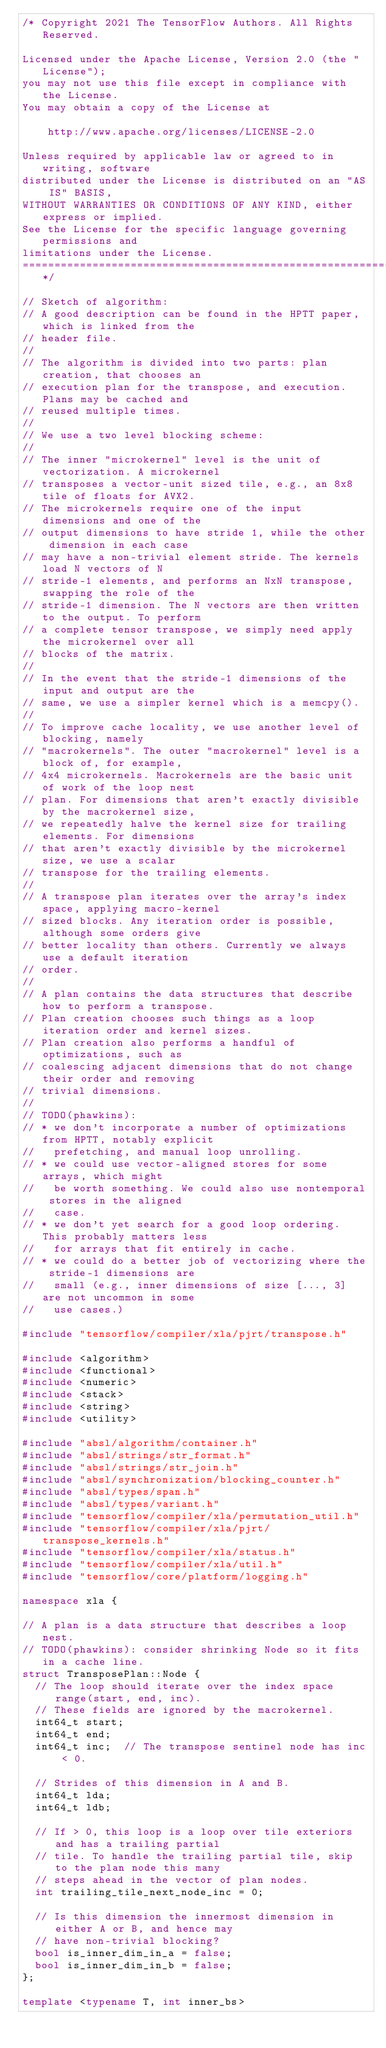<code> <loc_0><loc_0><loc_500><loc_500><_C++_>/* Copyright 2021 The TensorFlow Authors. All Rights Reserved.

Licensed under the Apache License, Version 2.0 (the "License");
you may not use this file except in compliance with the License.
You may obtain a copy of the License at

    http://www.apache.org/licenses/LICENSE-2.0

Unless required by applicable law or agreed to in writing, software
distributed under the License is distributed on an "AS IS" BASIS,
WITHOUT WARRANTIES OR CONDITIONS OF ANY KIND, either express or implied.
See the License for the specific language governing permissions and
limitations under the License.
==============================================================================*/

// Sketch of algorithm:
// A good description can be found in the HPTT paper, which is linked from the
// header file.
//
// The algorithm is divided into two parts: plan creation, that chooses an
// execution plan for the transpose, and execution. Plans may be cached and
// reused multiple times.
//
// We use a two level blocking scheme:
//
// The inner "microkernel" level is the unit of vectorization. A microkernel
// transposes a vector-unit sized tile, e.g., an 8x8 tile of floats for AVX2.
// The microkernels require one of the input dimensions and one of the
// output dimensions to have stride 1, while the other dimension in each case
// may have a non-trivial element stride. The kernels load N vectors of N
// stride-1 elements, and performs an NxN transpose, swapping the role of the
// stride-1 dimension. The N vectors are then written to the output. To perform
// a complete tensor transpose, we simply need apply the microkernel over all
// blocks of the matrix.
//
// In the event that the stride-1 dimensions of the input and output are the
// same, we use a simpler kernel which is a memcpy().
//
// To improve cache locality, we use another level of blocking, namely
// "macrokernels". The outer "macrokernel" level is a block of, for example,
// 4x4 microkernels. Macrokernels are the basic unit of work of the loop nest
// plan. For dimensions that aren't exactly divisible by the macrokernel size,
// we repeatedly halve the kernel size for trailing elements. For dimensions
// that aren't exactly divisible by the microkernel size, we use a scalar
// transpose for the trailing elements.
//
// A transpose plan iterates over the array's index space, applying macro-kernel
// sized blocks. Any iteration order is possible, although some orders give
// better locality than others. Currently we always use a default iteration
// order.
//
// A plan contains the data structures that describe how to perform a transpose.
// Plan creation chooses such things as a loop iteration order and kernel sizes.
// Plan creation also performs a handful of optimizations, such as
// coalescing adjacent dimensions that do not change their order and removing
// trivial dimensions.
//
// TODO(phawkins):
// * we don't incorporate a number of optimizations from HPTT, notably explicit
//   prefetching, and manual loop unrolling.
// * we could use vector-aligned stores for some arrays, which might
//   be worth something. We could also use nontemporal stores in the aligned
//   case.
// * we don't yet search for a good loop ordering. This probably matters less
//   for arrays that fit entirely in cache.
// * we could do a better job of vectorizing where the stride-1 dimensions are
//   small (e.g., inner dimensions of size [..., 3] are not uncommon in some
//   use cases.)

#include "tensorflow/compiler/xla/pjrt/transpose.h"

#include <algorithm>
#include <functional>
#include <numeric>
#include <stack>
#include <string>
#include <utility>

#include "absl/algorithm/container.h"
#include "absl/strings/str_format.h"
#include "absl/strings/str_join.h"
#include "absl/synchronization/blocking_counter.h"
#include "absl/types/span.h"
#include "absl/types/variant.h"
#include "tensorflow/compiler/xla/permutation_util.h"
#include "tensorflow/compiler/xla/pjrt/transpose_kernels.h"
#include "tensorflow/compiler/xla/status.h"
#include "tensorflow/compiler/xla/util.h"
#include "tensorflow/core/platform/logging.h"

namespace xla {

// A plan is a data structure that describes a loop nest.
// TODO(phawkins): consider shrinking Node so it fits in a cache line.
struct TransposePlan::Node {
  // The loop should iterate over the index space range(start, end, inc).
  // These fields are ignored by the macrokernel.
  int64_t start;
  int64_t end;
  int64_t inc;  // The transpose sentinel node has inc < 0.

  // Strides of this dimension in A and B.
  int64_t lda;
  int64_t ldb;

  // If > 0, this loop is a loop over tile exteriors and has a trailing partial
  // tile. To handle the trailing partial tile, skip to the plan node this many
  // steps ahead in the vector of plan nodes.
  int trailing_tile_next_node_inc = 0;

  // Is this dimension the innermost dimension in either A or B, and hence may
  // have non-trivial blocking?
  bool is_inner_dim_in_a = false;
  bool is_inner_dim_in_b = false;
};

template <typename T, int inner_bs></code> 